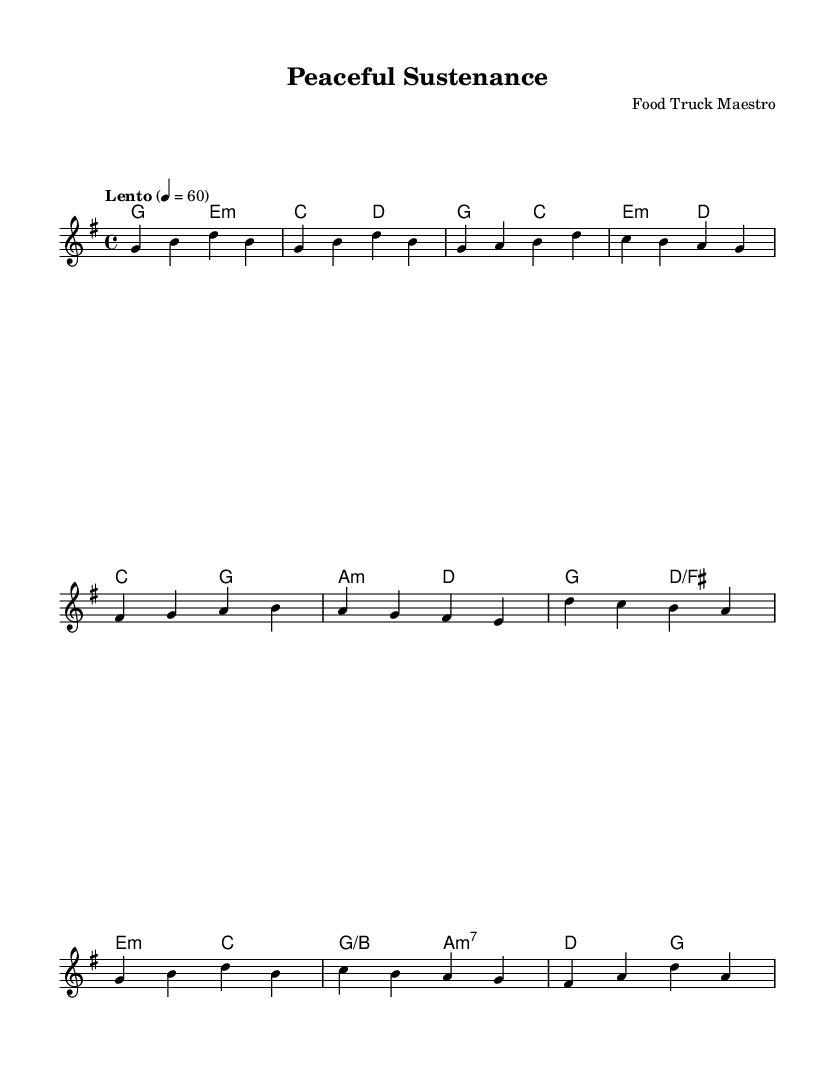What is the key signature of this music? The key signature is G major, which has one sharp (F#). You can determine this by looking for any sharps or flats indicated at the beginning of the staff.
Answer: G major What is the time signature of this piece? The time signature is 4/4, meaning there are four beats in a measure and a quarter note gets one beat. This can be identified by the numbers placed at the beginning of the music.
Answer: 4/4 What is the tempo marking for this piece? The tempo marking is Lento, which indicates a slow pace. You determine this by the word provided at the beginning of the score alongside the metronome marking.
Answer: Lento What is the root chord for the introduction? The root chord for the introduction is G major, as it is the first chord indicated in the harmonies section. You can find it listed at the start of the piece within the chord progression.
Answer: G major What is the final chord in the chorus section? The final chord in the chorus section is G major, which is the last chord listed in the harmonies corresponding to the chorus measures. You can find it after analyzing the harmony shown below the melody in the score.
Answer: G major How many measures are in the verse section? There are four measures in the verse section, as indicated by counting the distinct groups of notes between the chord symbols. By counting the measures specifically labeled "Verse" in the written structure, the count is confirmed.
Answer: 4 